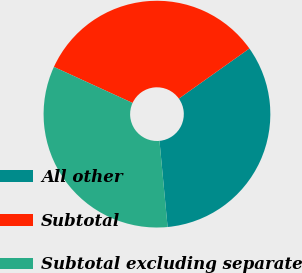Convert chart. <chart><loc_0><loc_0><loc_500><loc_500><pie_chart><fcel>All other<fcel>Subtotal<fcel>Subtotal excluding separate<nl><fcel>33.33%<fcel>33.33%<fcel>33.33%<nl></chart> 